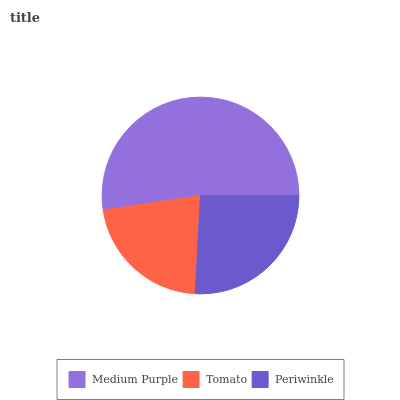Is Tomato the minimum?
Answer yes or no. Yes. Is Medium Purple the maximum?
Answer yes or no. Yes. Is Periwinkle the minimum?
Answer yes or no. No. Is Periwinkle the maximum?
Answer yes or no. No. Is Periwinkle greater than Tomato?
Answer yes or no. Yes. Is Tomato less than Periwinkle?
Answer yes or no. Yes. Is Tomato greater than Periwinkle?
Answer yes or no. No. Is Periwinkle less than Tomato?
Answer yes or no. No. Is Periwinkle the high median?
Answer yes or no. Yes. Is Periwinkle the low median?
Answer yes or no. Yes. Is Tomato the high median?
Answer yes or no. No. Is Tomato the low median?
Answer yes or no. No. 